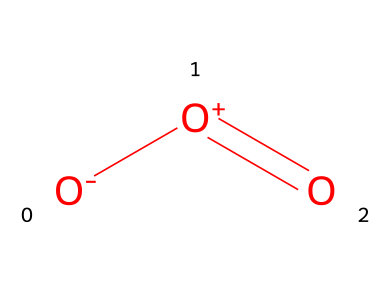What is the name of this chemical? The provided chemical structure corresponds to ozone, a triatomic molecule consisting of three oxygen atoms.
Answer: ozone How many oxygen atoms are present in the structure? The SMILES representation indicates there are three oxygen atoms present in the molecule, matching the structure of ozone.
Answer: three What type of bonding is present between the oxygen atoms? In the SMILES structure, there is a double bond between one pair of oxygen atoms and a single bond with the other, indicating a combination of single and double bonding in ozone.
Answer: mixed bonding What is the oxidation state of the central oxygen atom? In the structure, the central oxygen is between a positively charged oxygen and a negatively charged oxygen, making its oxidation state +1.
Answer: +1 How does ozone act as an oxidizer? Ozone can readily donate oxygen and react with other substances, often accepting electrons from them, which classifies it as a strong oxidizer in chemical reactions.
Answer: strong oxidizer What is one potential application of ozone in forensic science? Ozone can be useful for the decontamination of crime scenes by breaking down organic materials and aiding in the removal of odors.
Answer: decontamination 